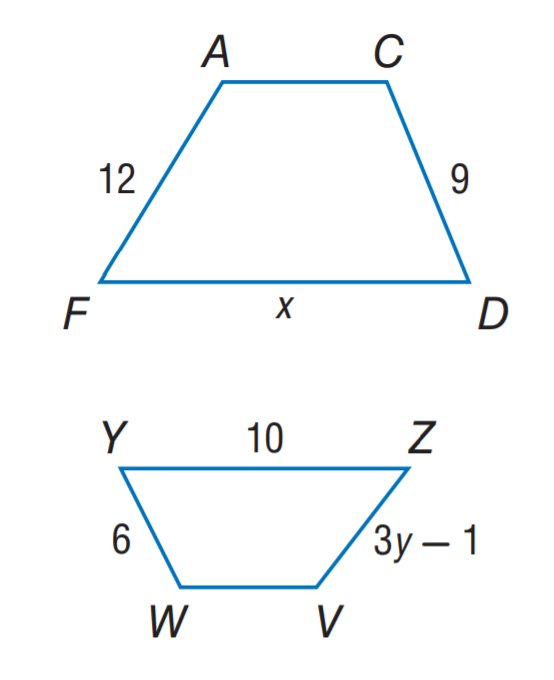Answer the mathemtical geometry problem and directly provide the correct option letter.
Question: A C D F \sim V W Y Z. Find y.
Choices: A: 3 B: 5 C: 6 D: 9 A 